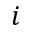<formula> <loc_0><loc_0><loc_500><loc_500>i</formula> 